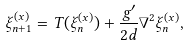<formula> <loc_0><loc_0><loc_500><loc_500>\xi _ { n + 1 } ^ { ( x ) } = T ( \xi _ { n } ^ { ( x ) } ) + \frac { g ^ { \prime } } { 2 d } \nabla ^ { 2 } \xi _ { n } ^ { ( x ) } ,</formula> 